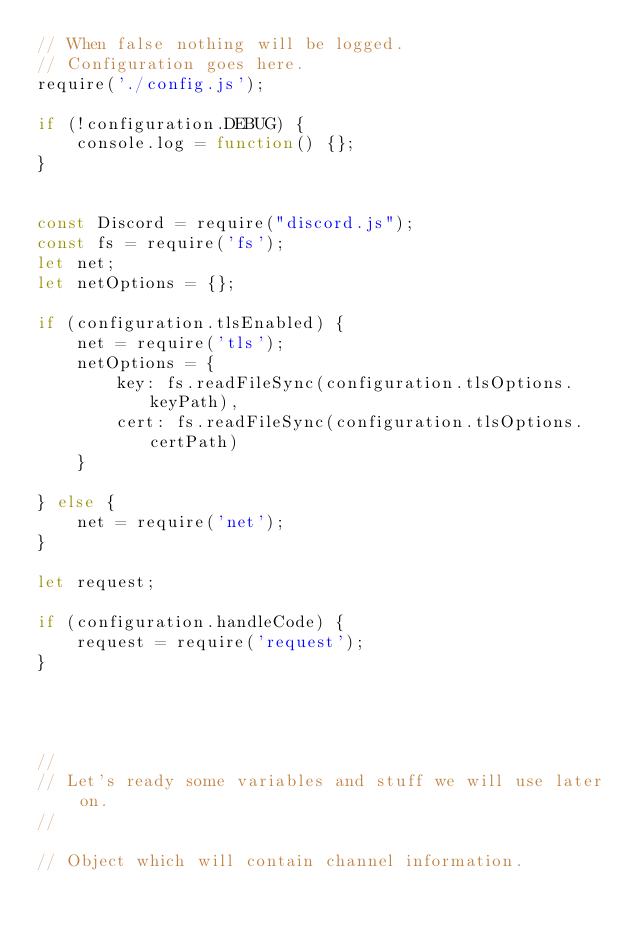<code> <loc_0><loc_0><loc_500><loc_500><_JavaScript_>// When false nothing will be logged. 
// Configuration goes here.
require('./config.js');

if (!configuration.DEBUG) {
    console.log = function() {};
}


const Discord = require("discord.js");
const fs = require('fs');
let net;
let netOptions = {};

if (configuration.tlsEnabled) {
    net = require('tls');
    netOptions = {
        key: fs.readFileSync(configuration.tlsOptions.keyPath),
        cert: fs.readFileSync(configuration.tlsOptions.certPath)
    }

} else {
    net = require('net');
}

let request;

if (configuration.handleCode) {
    request = require('request');
}




//
// Let's ready some variables and stuff we will use later on.
//

// Object which will contain channel information.</code> 